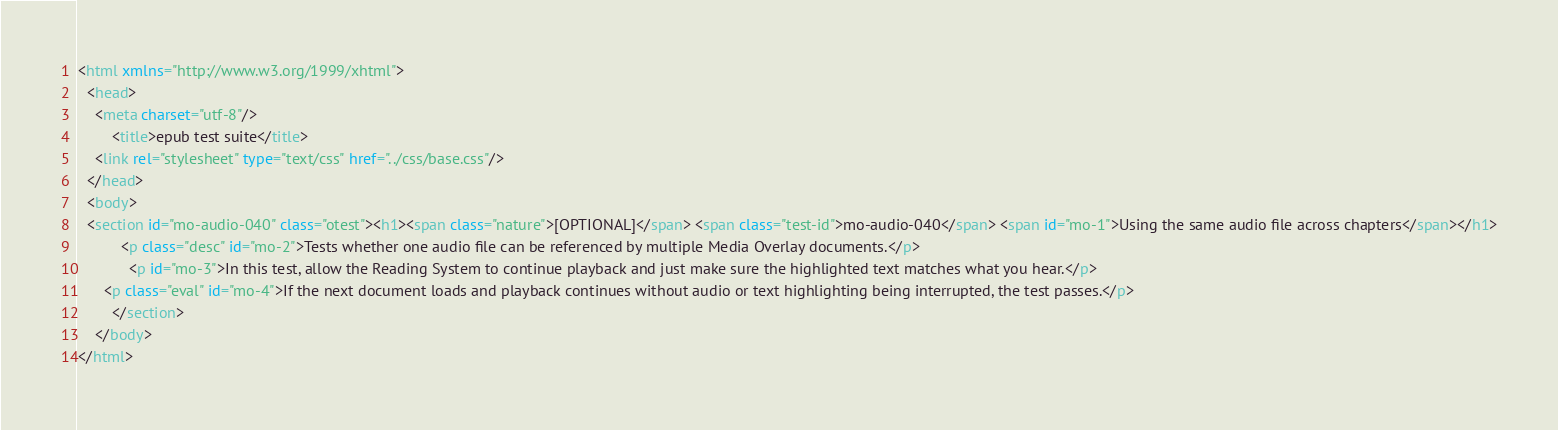<code> <loc_0><loc_0><loc_500><loc_500><_HTML_><html xmlns="http://www.w3.org/1999/xhtml">
  <head>
    <meta charset="utf-8"/>
		<title>epub test suite</title>
    <link rel="stylesheet" type="text/css" href="../css/base.css"/>
  </head>
  <body>
  <section id="mo-audio-040" class="otest"><h1><span class="nature">[OPTIONAL]</span> <span class="test-id">mo-audio-040</span> <span id="mo-1">Using the same audio file across chapters</span></h1>
          <p class="desc" id="mo-2">Tests whether one audio file can be referenced by multiple Media Overlay documents.</p>
            <p id="mo-3">In this test, allow the Reading System to continue playback and just make sure the highlighted text matches what you hear.</p>
      <p class="eval" id="mo-4">If the next document loads and playback continues without audio or text highlighting being interrupted, the test passes.</p>
        </section>
    </body>
</html>
</code> 